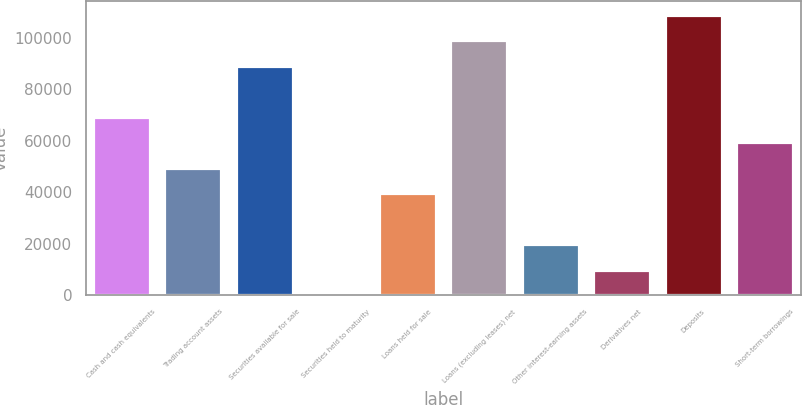Convert chart to OTSL. <chart><loc_0><loc_0><loc_500><loc_500><bar_chart><fcel>Cash and cash equivalents<fcel>Trading account assets<fcel>Securities available for sale<fcel>Securities held to maturity<fcel>Loans held for sale<fcel>Loans (excluding leases) net<fcel>Other interest-earning assets<fcel>Derivatives net<fcel>Deposits<fcel>Short-term borrowings<nl><fcel>69426.9<fcel>49599.5<fcel>89254.3<fcel>31<fcel>39685.8<fcel>99168<fcel>19858.4<fcel>9944.7<fcel>109082<fcel>59513.2<nl></chart> 